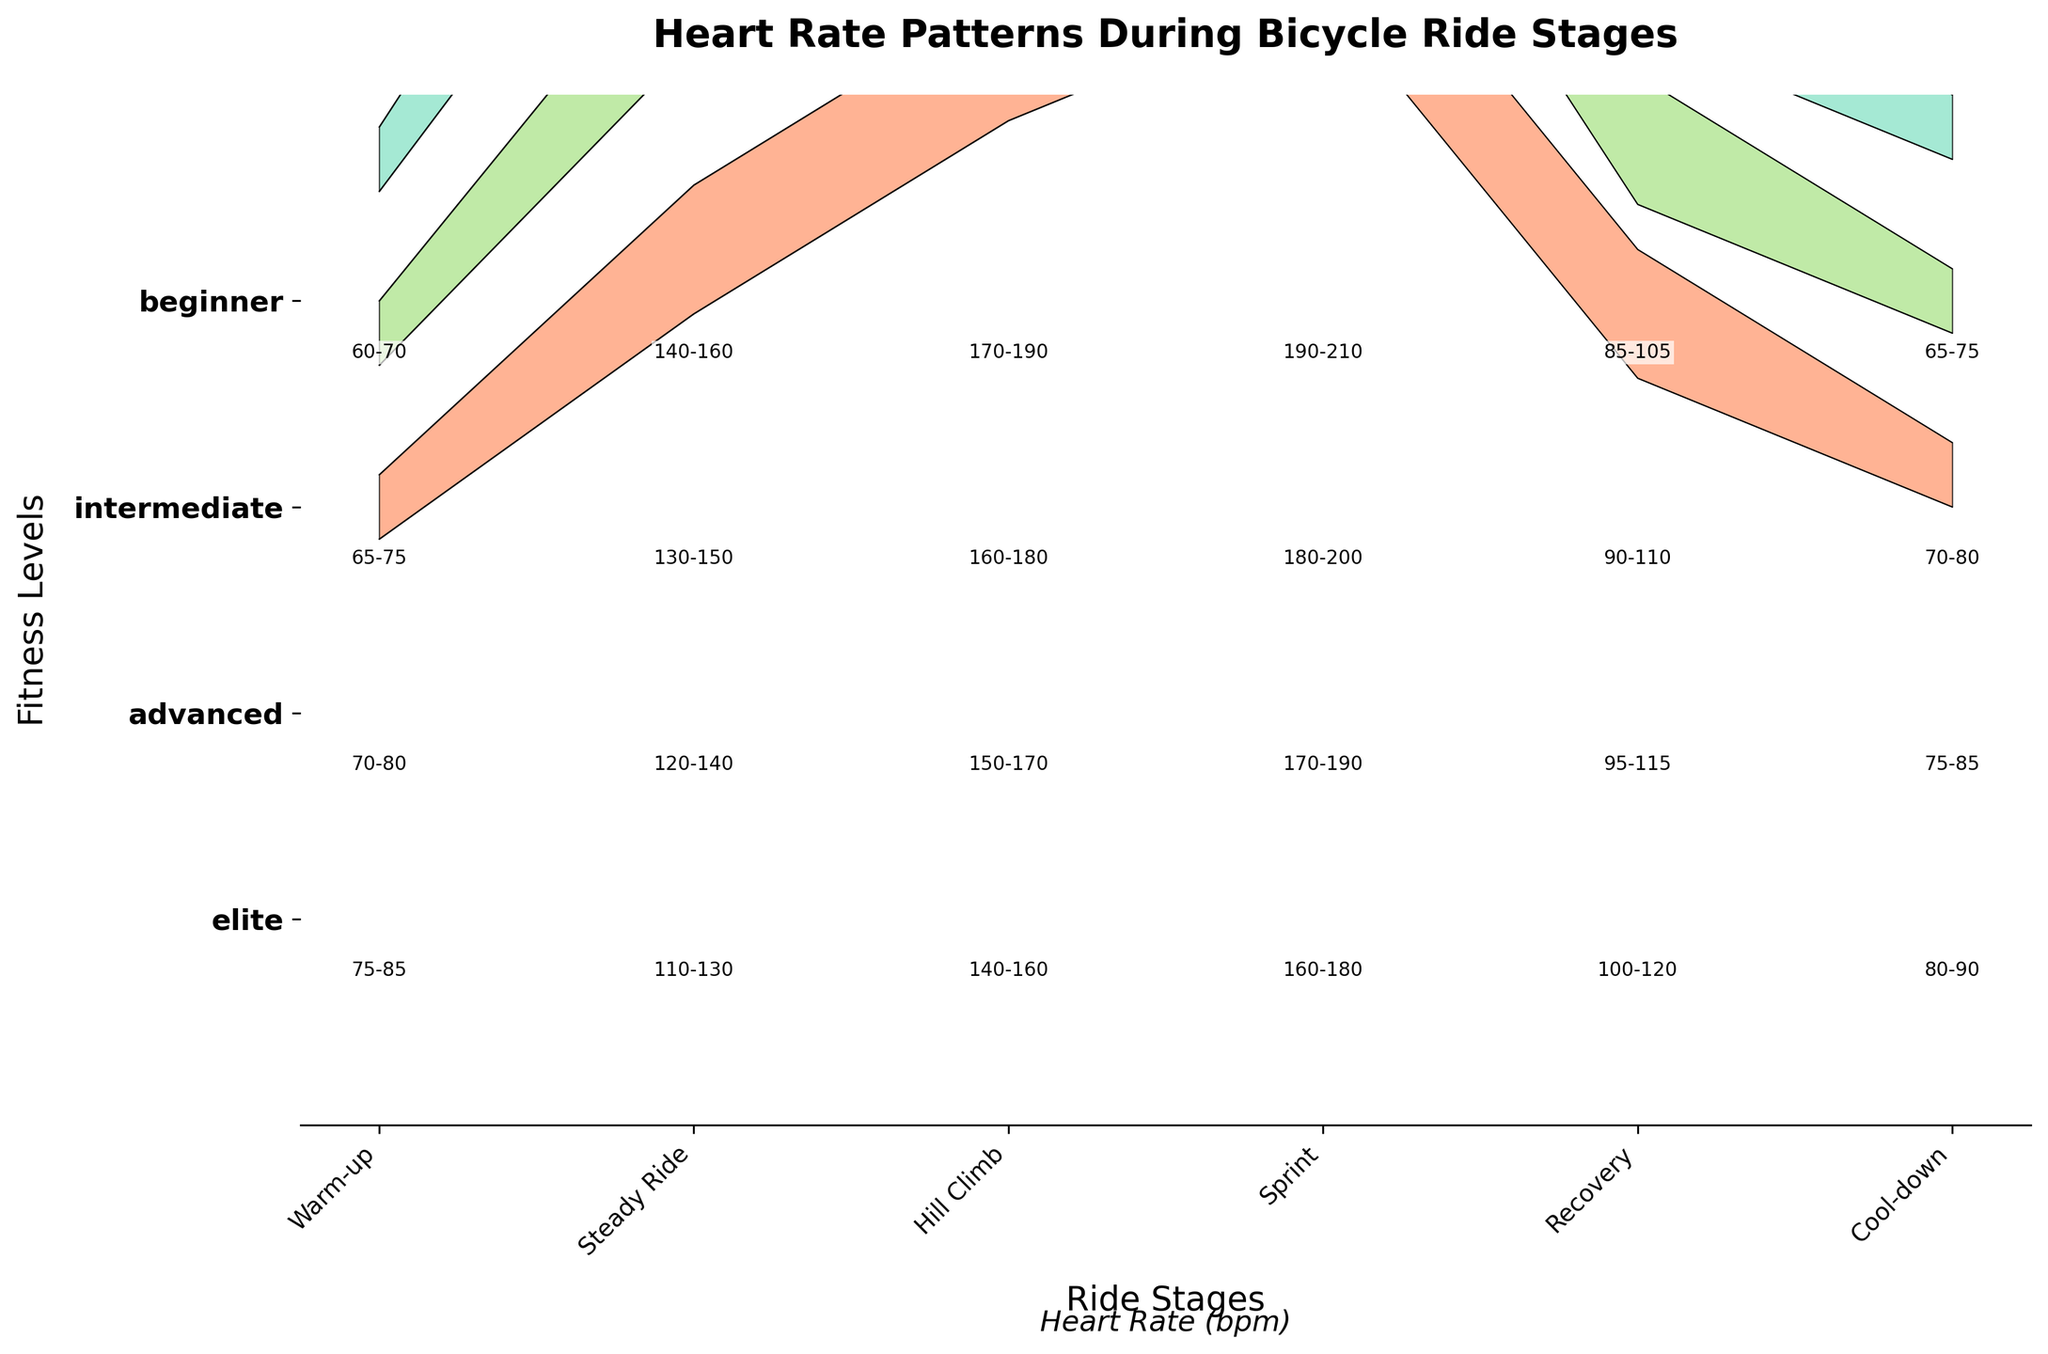what are the heart rate ranges for beginners during the hill climb stage? To determine this, look at the "Hill Climb" stage and the range indicated for "beginner," which is listed as 140–160 bpm.
Answer: 140–160 bpm what is the difference in heart rate range between the warm-up and the hill climb stage for intermediates? The heart rate range for intermediates during the warm-up is 70-80 bpm, and for the hill climb, it is 150-170 bpm. Calculating the difference: Hill Climb range: 150-170 - Warm-up range: 70-80 = 80 bpm in the lower range and 90 bpm in the upper range.
Answer: 80-90 bpm during which stage does the heart rate have the highest maximum value for elite cyclists? To find the maximum heart rate for elite cyclists, observe each stage and identify the highest value. The sprint stage has the highest maximum value of 210 bpm.
Answer: Sprint stage how does the heart rate range change from the steady ride to the sprint stage for advanced cyclists? The heart rate range for advanced cyclists during the steady ride is 130-150 bpm and for the sprint stage, it is 180-200 bpm. To see the change, subtract the steady ride values from the sprint values: (180-130 = 50 bpm increase in minimum) and (200-150 = 50 bpm increase in maximum).
Answer: 50 bpm increase which fitness level has the narrowest heart rate range during the recovery stage? To find this, compare the heart rate ranges of different fitness levels during the recovery stage. Beginner: 100-120 bpm (20 bpm), Intermediate: 95-115 bpm (20 bpm), Advanced: 90-110 bpm (20 bpm), Elite: 85-105 bpm (20 bpm). They are all equal.
Answer: All levels have a 20 bpm range what can you say about heart rate patterns as fitness levels improve during the hill climb stage? As fitness levels improve, heart rates during the hill climb stage also increase. Beginner: 140-160 bpm, Intermediate: 150-170 bpm, Advanced: 160-180 bpm, Elite: 170-190 bpm. This progression shows a higher tolerance for intense physical activity.
Answer: Heart rates increase with fitness levels in which stage is the heart rate range for beginners closest to the heart rate range for elites? Compare the ranges for beginners and elites across all stages. The warm-up stage has the closest overlapping ranges: Beginner: 75-85 bpm, Elite: 60-70 bpm. Difference in overlapping range: 75-60 = 15 bpm (smallest).
Answer: Warm-up stage what is the average heart rate range for intermediates across all stages? Calculate the average range by taking the sum of the minimum and maximum heart rates for each stage and dividing by the number of stages. [(75+85)+(120+140)+(150+170)+(170+190)+(95+115)+(75+85)]/6 = Average min: (75+120+150+170+95+75)/6 = 114 bpm; Average max: (85+140+170+190+115+85)/6 = 130 bpm
Answer: 114-130 bpm 